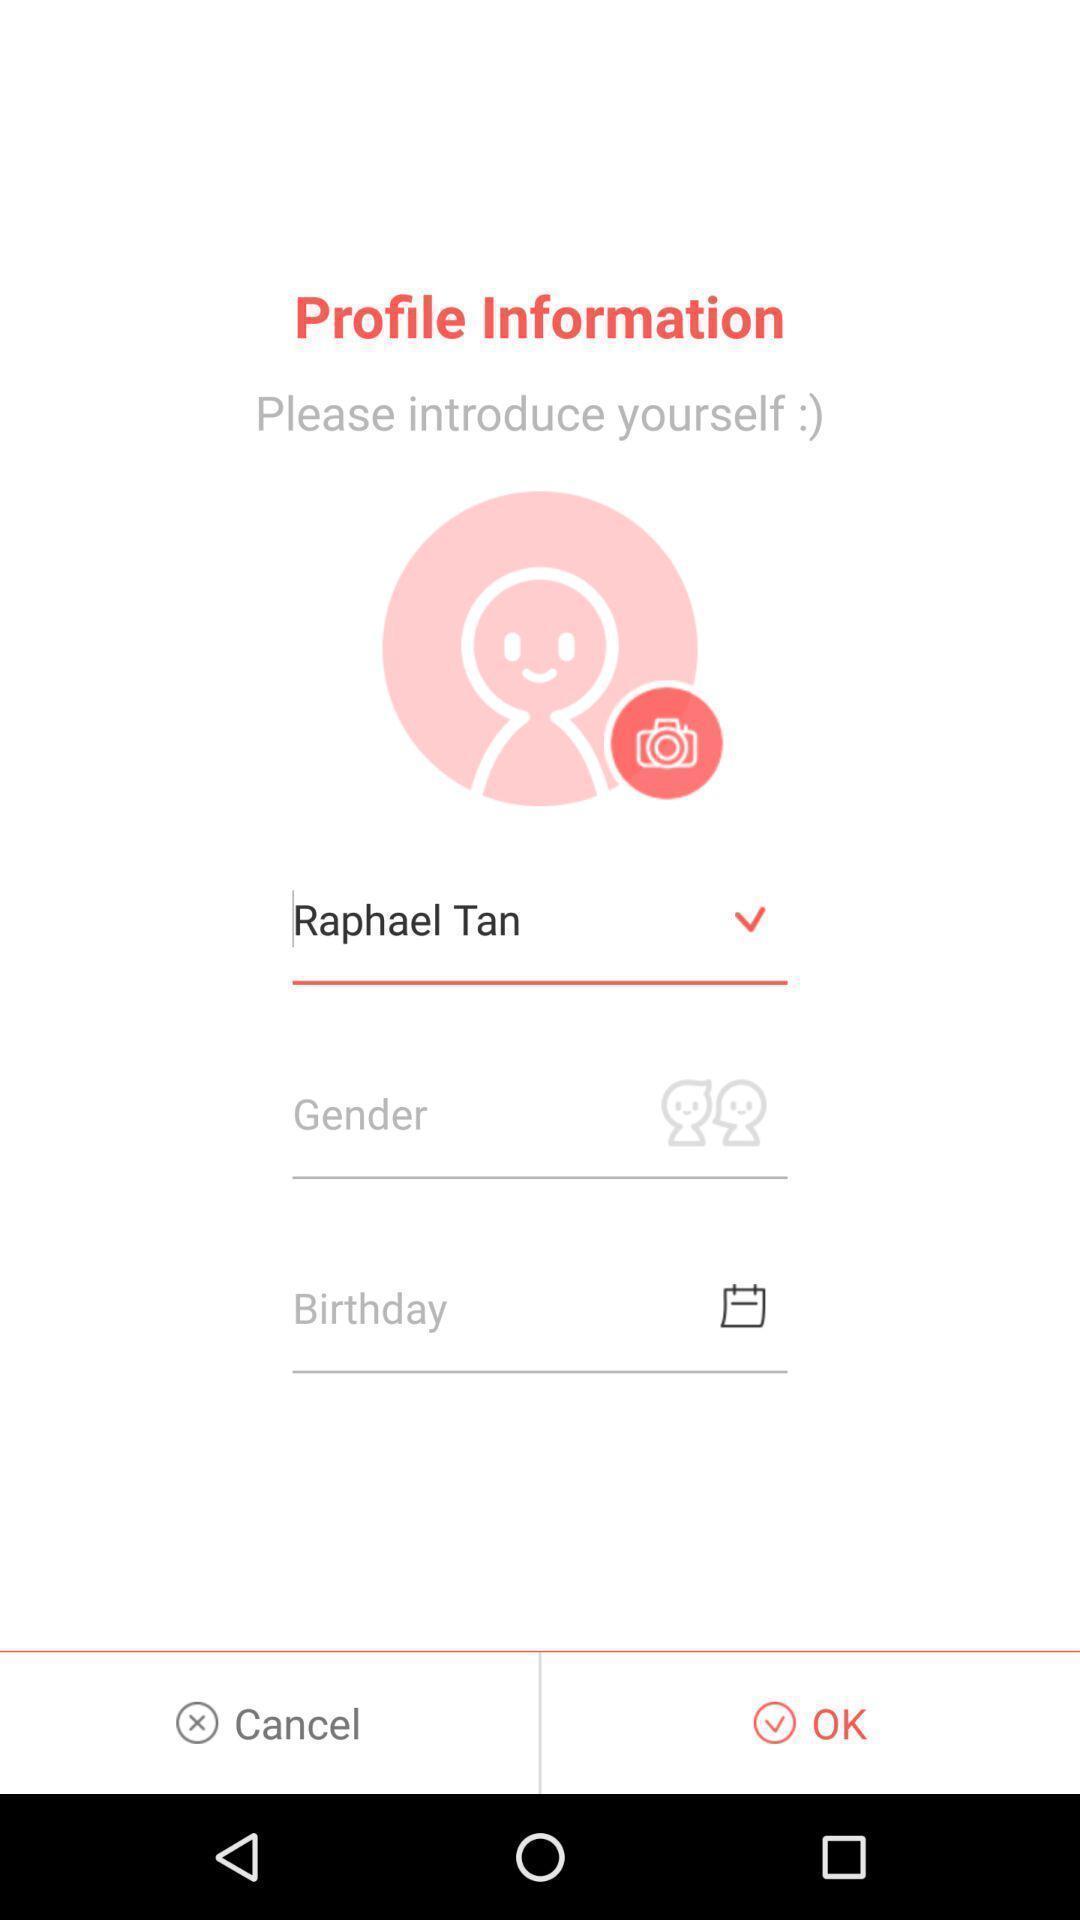Describe the key features of this screenshot. Screen page of a profile information. 